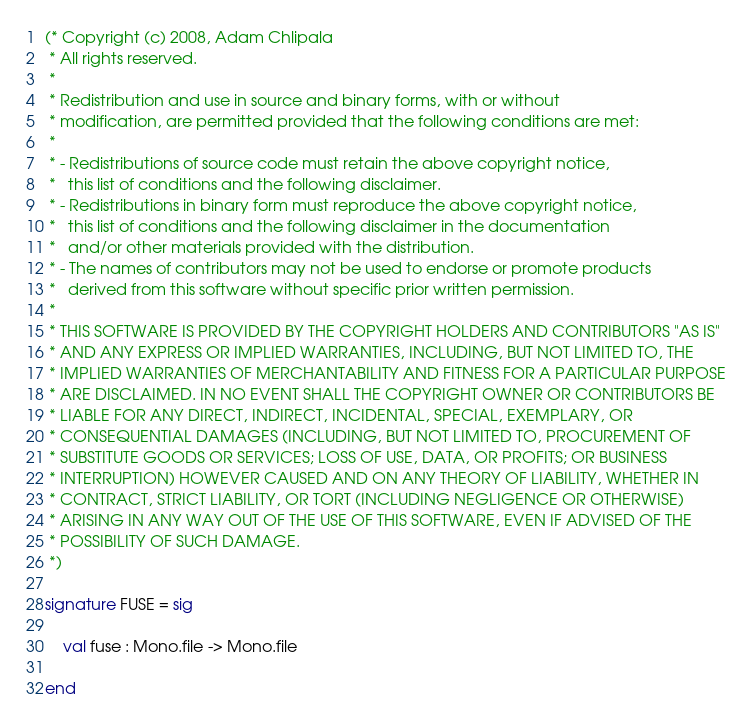Convert code to text. <code><loc_0><loc_0><loc_500><loc_500><_SML_>(* Copyright (c) 2008, Adam Chlipala
 * All rights reserved.
 *
 * Redistribution and use in source and binary forms, with or without
 * modification, are permitted provided that the following conditions are met:
 *
 * - Redistributions of source code must retain the above copyright notice,
 *   this list of conditions and the following disclaimer.
 * - Redistributions in binary form must reproduce the above copyright notice,
 *   this list of conditions and the following disclaimer in the documentation
 *   and/or other materials provided with the distribution.
 * - The names of contributors may not be used to endorse or promote products
 *   derived from this software without specific prior written permission.
 *
 * THIS SOFTWARE IS PROVIDED BY THE COPYRIGHT HOLDERS AND CONTRIBUTORS "AS IS"
 * AND ANY EXPRESS OR IMPLIED WARRANTIES, INCLUDING, BUT NOT LIMITED TO, THE
 * IMPLIED WARRANTIES OF MERCHANTABILITY AND FITNESS FOR A PARTICULAR PURPOSE
 * ARE DISCLAIMED. IN NO EVENT SHALL THE COPYRIGHT OWNER OR CONTRIBUTORS BE
 * LIABLE FOR ANY DIRECT, INDIRECT, INCIDENTAL, SPECIAL, EXEMPLARY, OR 
 * CONSEQUENTIAL DAMAGES (INCLUDING, BUT NOT LIMITED TO, PROCUREMENT OF
 * SUBSTITUTE GOODS OR SERVICES; LOSS OF USE, DATA, OR PROFITS; OR BUSINESS
 * INTERRUPTION) HOWEVER CAUSED AND ON ANY THEORY OF LIABILITY, WHETHER IN
 * CONTRACT, STRICT LIABILITY, OR TORT (INCLUDING NEGLIGENCE OR OTHERWISE)
 * ARISING IN ANY WAY OUT OF THE USE OF THIS SOFTWARE, EVEN IF ADVISED OF THE
 * POSSIBILITY OF SUCH DAMAGE.
 *)

signature FUSE = sig

    val fuse : Mono.file -> Mono.file

end
</code> 